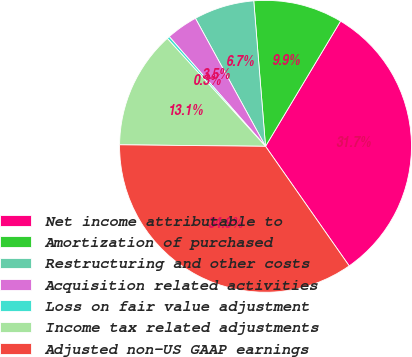Convert chart. <chart><loc_0><loc_0><loc_500><loc_500><pie_chart><fcel>Net income attributable to<fcel>Amortization of purchased<fcel>Restructuring and other costs<fcel>Acquisition related activities<fcel>Loss on fair value adjustment<fcel>Income tax related adjustments<fcel>Adjusted non-US GAAP earnings<nl><fcel>31.69%<fcel>9.88%<fcel>6.69%<fcel>3.49%<fcel>0.29%<fcel>13.08%<fcel>34.88%<nl></chart> 